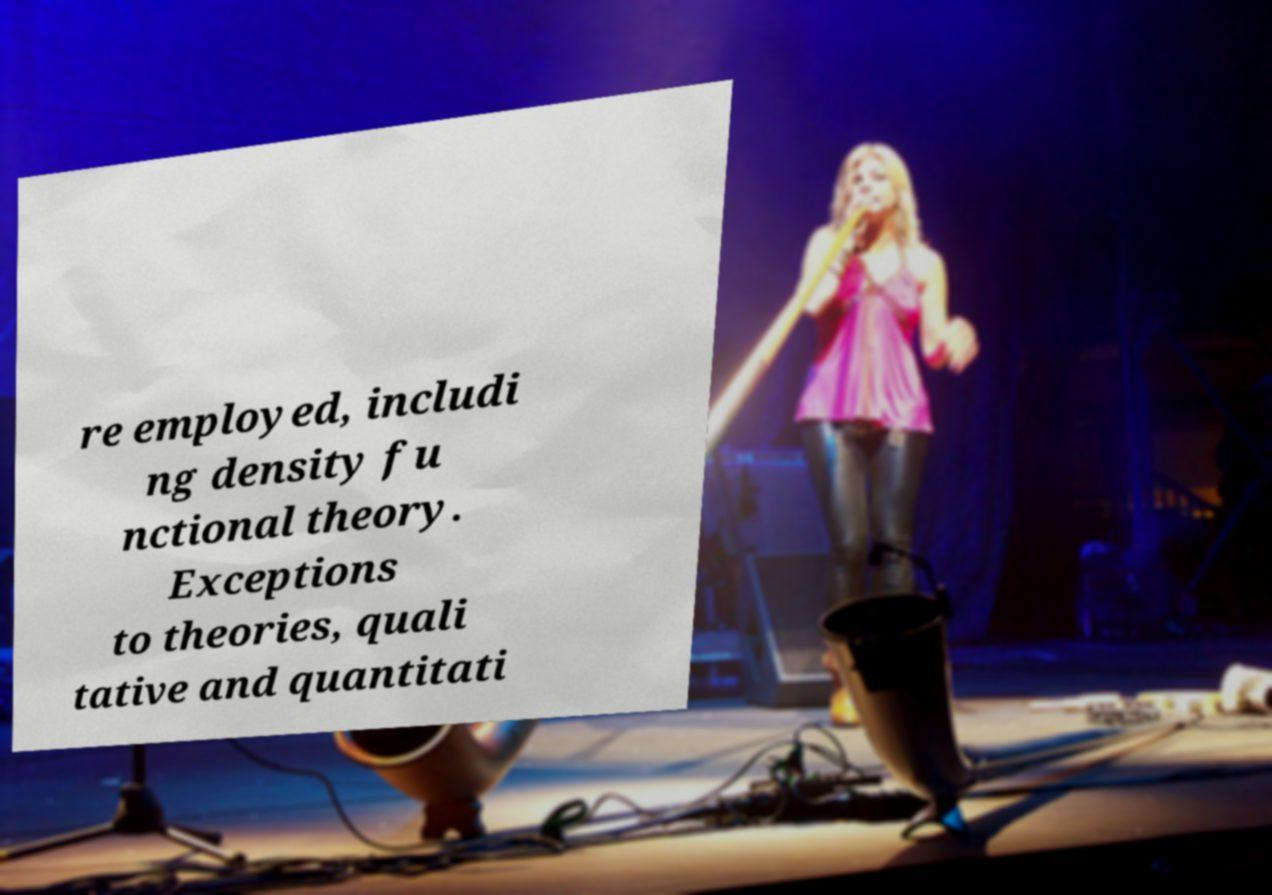For documentation purposes, I need the text within this image transcribed. Could you provide that? re employed, includi ng density fu nctional theory. Exceptions to theories, quali tative and quantitati 